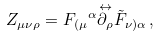Convert formula to latex. <formula><loc_0><loc_0><loc_500><loc_500>Z _ { \mu \nu \rho } = { F _ { ( \mu } } ^ { \alpha } \overset { \leftrightarrow } { \partial _ { \rho } } \tilde { F } _ { \nu ) \alpha } \, ,</formula> 